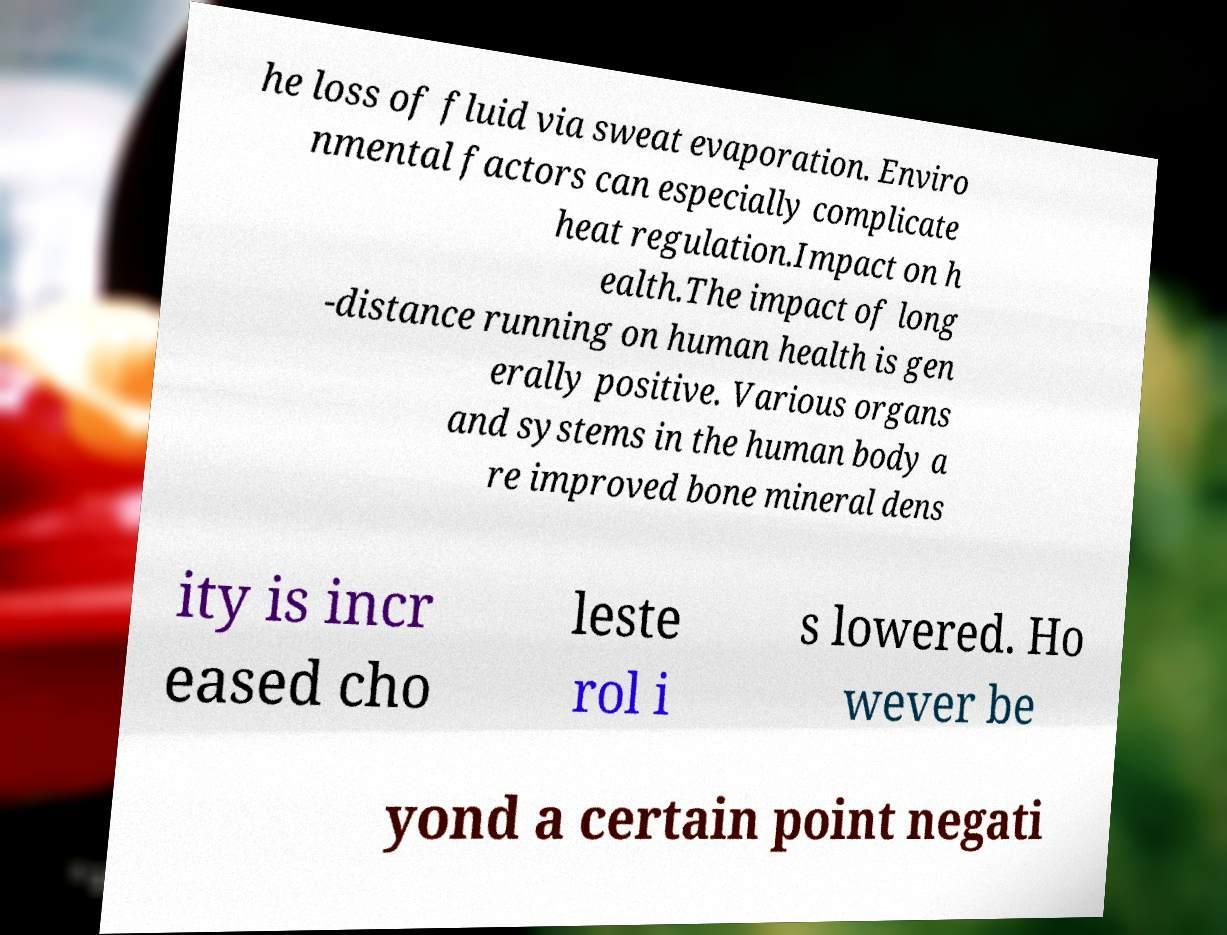Can you read and provide the text displayed in the image?This photo seems to have some interesting text. Can you extract and type it out for me? he loss of fluid via sweat evaporation. Enviro nmental factors can especially complicate heat regulation.Impact on h ealth.The impact of long -distance running on human health is gen erally positive. Various organs and systems in the human body a re improved bone mineral dens ity is incr eased cho leste rol i s lowered. Ho wever be yond a certain point negati 